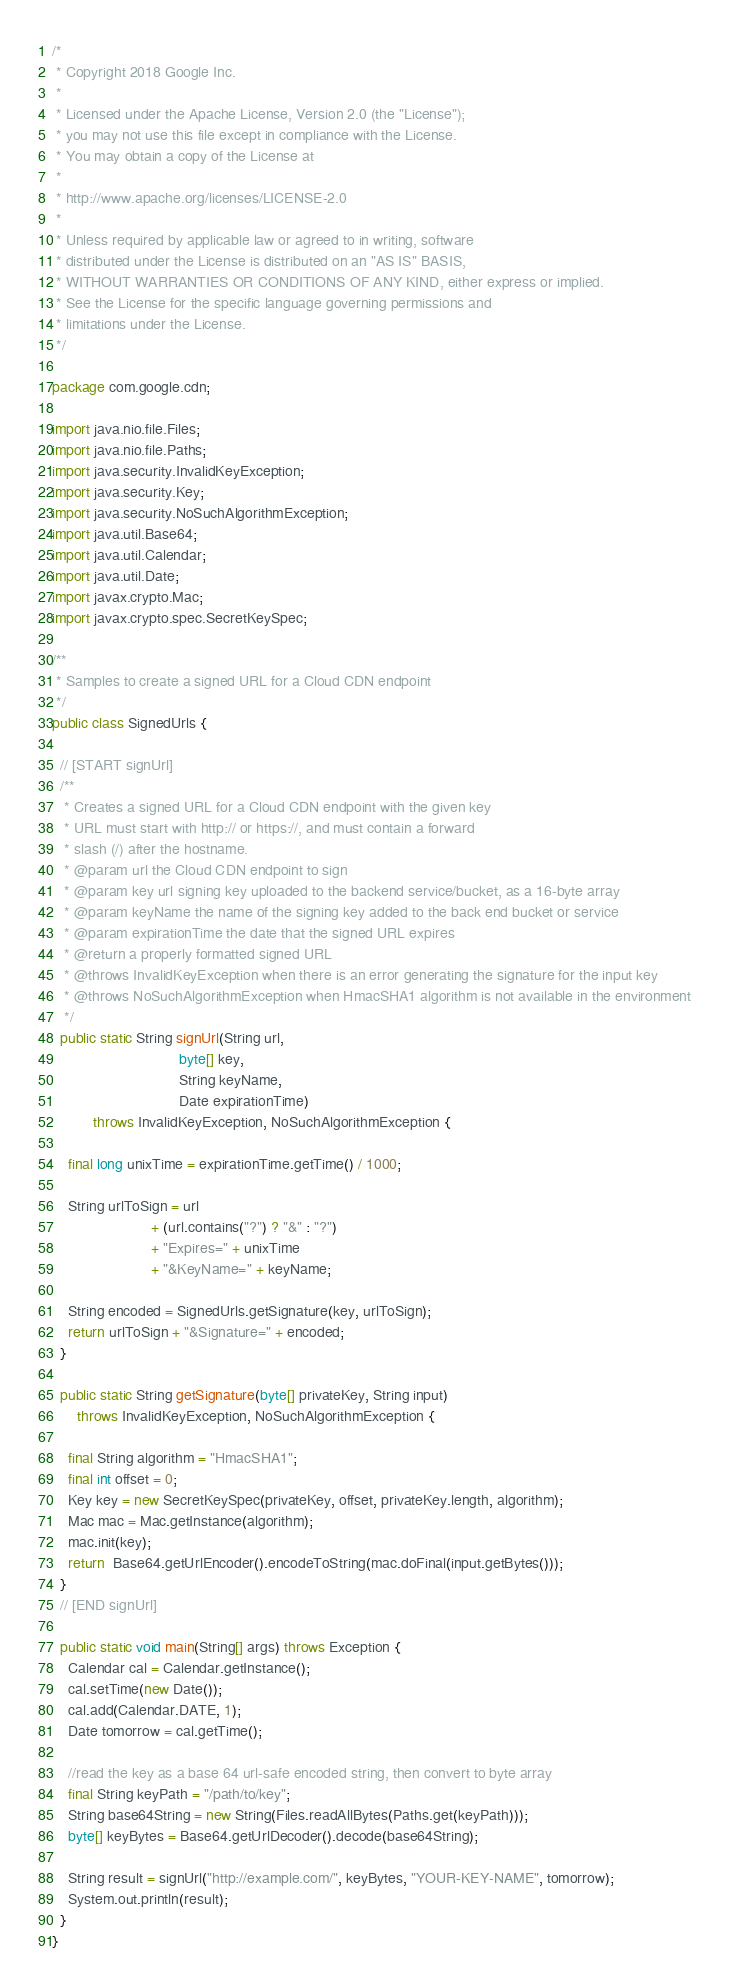<code> <loc_0><loc_0><loc_500><loc_500><_Java_>/*
 * Copyright 2018 Google Inc.
 *
 * Licensed under the Apache License, Version 2.0 (the "License");
 * you may not use this file except in compliance with the License.
 * You may obtain a copy of the License at
 *
 * http://www.apache.org/licenses/LICENSE-2.0
 *
 * Unless required by applicable law or agreed to in writing, software
 * distributed under the License is distributed on an "AS IS" BASIS,
 * WITHOUT WARRANTIES OR CONDITIONS OF ANY KIND, either express or implied.
 * See the License for the specific language governing permissions and
 * limitations under the License.
 */

package com.google.cdn;

import java.nio.file.Files;
import java.nio.file.Paths;
import java.security.InvalidKeyException;
import java.security.Key;
import java.security.NoSuchAlgorithmException;
import java.util.Base64;
import java.util.Calendar;
import java.util.Date;
import javax.crypto.Mac;
import javax.crypto.spec.SecretKeySpec;

/**
 * Samples to create a signed URL for a Cloud CDN endpoint
 */
public class SignedUrls {

  // [START signUrl]
  /**
   * Creates a signed URL for a Cloud CDN endpoint with the given key
   * URL must start with http:// or https://, and must contain a forward
   * slash (/) after the hostname.
   * @param url the Cloud CDN endpoint to sign
   * @param key url signing key uploaded to the backend service/bucket, as a 16-byte array
   * @param keyName the name of the signing key added to the back end bucket or service
   * @param expirationTime the date that the signed URL expires
   * @return a properly formatted signed URL
   * @throws InvalidKeyException when there is an error generating the signature for the input key
   * @throws NoSuchAlgorithmException when HmacSHA1 algorithm is not available in the environment
   */
  public static String signUrl(String url,
                               byte[] key,
                               String keyName,
                               Date expirationTime)
          throws InvalidKeyException, NoSuchAlgorithmException {

    final long unixTime = expirationTime.getTime() / 1000;

    String urlToSign = url
                        + (url.contains("?") ? "&" : "?")
                        + "Expires=" + unixTime
                        + "&KeyName=" + keyName;

    String encoded = SignedUrls.getSignature(key, urlToSign);
    return urlToSign + "&Signature=" + encoded;
  }

  public static String getSignature(byte[] privateKey, String input)
      throws InvalidKeyException, NoSuchAlgorithmException {

    final String algorithm = "HmacSHA1";
    final int offset = 0;
    Key key = new SecretKeySpec(privateKey, offset, privateKey.length, algorithm);
    Mac mac = Mac.getInstance(algorithm);
    mac.init(key);
    return  Base64.getUrlEncoder().encodeToString(mac.doFinal(input.getBytes()));
  }
  // [END signUrl]

  public static void main(String[] args) throws Exception {
    Calendar cal = Calendar.getInstance();
    cal.setTime(new Date());
    cal.add(Calendar.DATE, 1);
    Date tomorrow = cal.getTime();

    //read the key as a base 64 url-safe encoded string, then convert to byte array
    final String keyPath = "/path/to/key";
    String base64String = new String(Files.readAllBytes(Paths.get(keyPath)));
    byte[] keyBytes = Base64.getUrlDecoder().decode(base64String);

    String result = signUrl("http://example.com/", keyBytes, "YOUR-KEY-NAME", tomorrow);
    System.out.println(result);
  }
}
</code> 